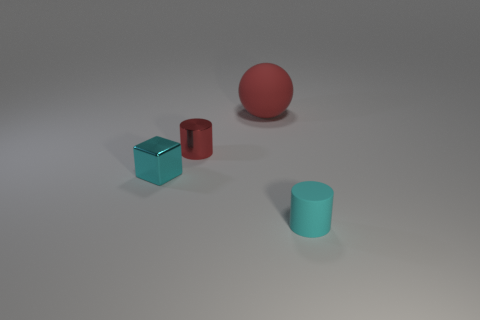Add 3 cyan matte things. How many objects exist? 7 Subtract all balls. How many objects are left? 3 Add 3 gray cylinders. How many gray cylinders exist? 3 Subtract 0 blue spheres. How many objects are left? 4 Subtract all cylinders. Subtract all red metal cylinders. How many objects are left? 1 Add 1 tiny matte cylinders. How many tiny matte cylinders are left? 2 